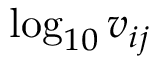Convert formula to latex. <formula><loc_0><loc_0><loc_500><loc_500>\log _ { 1 0 } v _ { i j }</formula> 